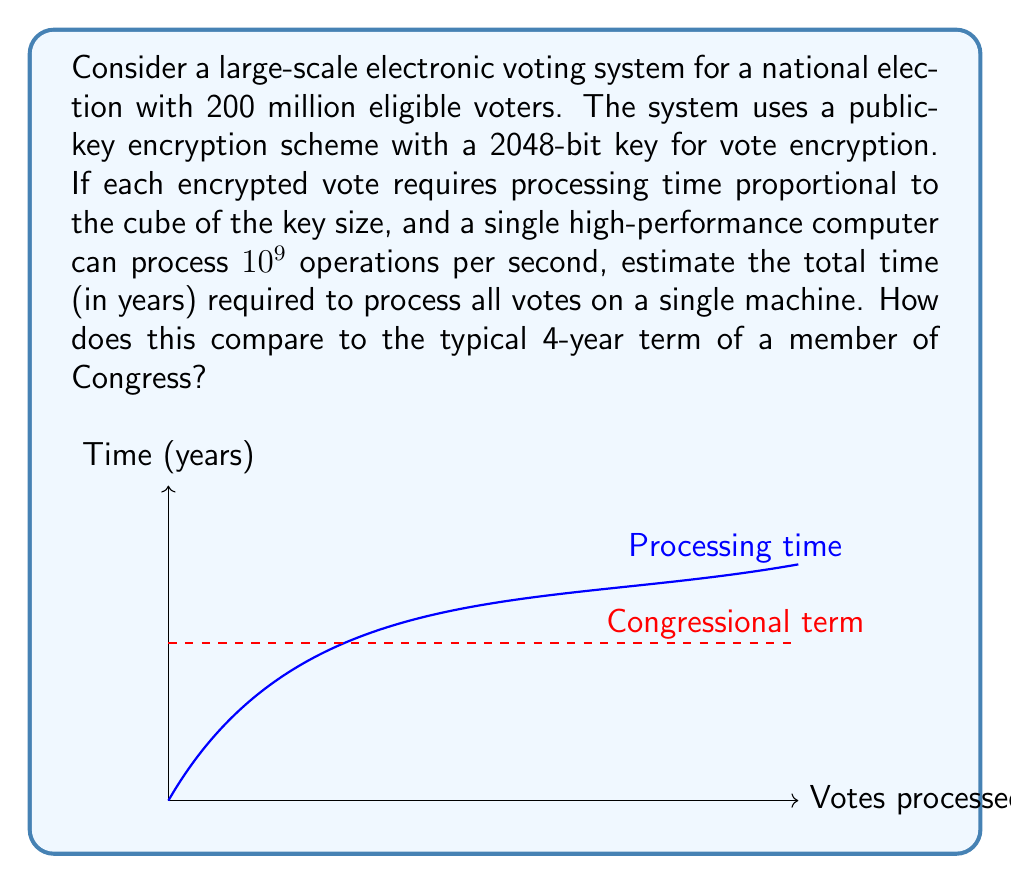Give your solution to this math problem. Let's approach this step-by-step:

1) First, we need to calculate the number of operations required to process a single vote:
   - Key size = 2048 bits
   - Processing time $\propto$ (key size)³
   - Operations per vote = $2048^3 = 8,589,934,592$

2) Now, let's calculate the total number of operations for all votes:
   - Number of voters = 200 million = $2 \times 10^8$
   - Total operations = $8,589,934,592 \times 2 \times 10^8 = 1.7179869184 \times 10^{18}$

3) Given the processing power of the computer:
   - Operations per second = $10^9$
   - Seconds required = $\frac{1.7179869184 \times 10^{18}}{10^9} = 1.7179869184 \times 10^9$

4) Convert seconds to years:
   - Seconds in a year = $365 \times 24 \times 60 \times 60 = 31,536,000$
   - Years required = $\frac{1.7179869184 \times 10^9}{31,536,000} \approx 54.48$ years

5) Compare to a Congressional term:
   - Congressional term = 4 years
   - Ratio = $\frac{54.48}{4} \approx 13.62$

Therefore, processing all votes would take approximately 54.48 years, which is about 13.62 times longer than a typical Congressional term.
Answer: 54.48 years, 13.62 times a Congressional term 